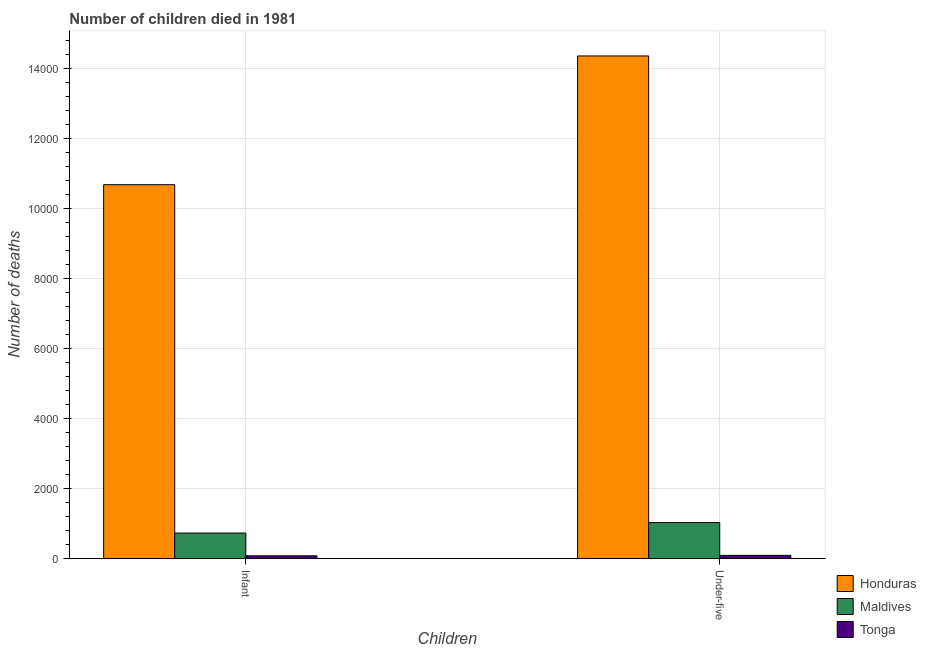How many different coloured bars are there?
Offer a terse response. 3. How many groups of bars are there?
Provide a succinct answer. 2. Are the number of bars on each tick of the X-axis equal?
Make the answer very short. Yes. How many bars are there on the 1st tick from the right?
Offer a terse response. 3. What is the label of the 1st group of bars from the left?
Your answer should be very brief. Infant. What is the number of under-five deaths in Maldives?
Your response must be concise. 1028. Across all countries, what is the maximum number of infant deaths?
Provide a short and direct response. 1.07e+04. Across all countries, what is the minimum number of under-five deaths?
Keep it short and to the point. 91. In which country was the number of under-five deaths maximum?
Make the answer very short. Honduras. In which country was the number of infant deaths minimum?
Give a very brief answer. Tonga. What is the total number of under-five deaths in the graph?
Offer a very short reply. 1.55e+04. What is the difference between the number of under-five deaths in Maldives and that in Tonga?
Your answer should be very brief. 937. What is the difference between the number of infant deaths in Maldives and the number of under-five deaths in Honduras?
Offer a very short reply. -1.36e+04. What is the average number of under-five deaths per country?
Give a very brief answer. 5157.67. What is the difference between the number of under-five deaths and number of infant deaths in Tonga?
Provide a short and direct response. 12. What is the ratio of the number of infant deaths in Honduras to that in Tonga?
Make the answer very short. 135.16. In how many countries, is the number of infant deaths greater than the average number of infant deaths taken over all countries?
Offer a terse response. 1. What does the 1st bar from the left in Under-five represents?
Make the answer very short. Honduras. What does the 1st bar from the right in Under-five represents?
Ensure brevity in your answer.  Tonga. Are all the bars in the graph horizontal?
Your response must be concise. No. Where does the legend appear in the graph?
Offer a very short reply. Bottom right. How many legend labels are there?
Provide a succinct answer. 3. How are the legend labels stacked?
Your answer should be compact. Vertical. What is the title of the graph?
Make the answer very short. Number of children died in 1981. Does "Madagascar" appear as one of the legend labels in the graph?
Ensure brevity in your answer.  No. What is the label or title of the X-axis?
Ensure brevity in your answer.  Children. What is the label or title of the Y-axis?
Make the answer very short. Number of deaths. What is the Number of deaths in Honduras in Infant?
Make the answer very short. 1.07e+04. What is the Number of deaths of Maldives in Infant?
Offer a terse response. 729. What is the Number of deaths of Tonga in Infant?
Provide a succinct answer. 79. What is the Number of deaths in Honduras in Under-five?
Keep it short and to the point. 1.44e+04. What is the Number of deaths in Maldives in Under-five?
Your response must be concise. 1028. What is the Number of deaths in Tonga in Under-five?
Your answer should be compact. 91. Across all Children, what is the maximum Number of deaths in Honduras?
Make the answer very short. 1.44e+04. Across all Children, what is the maximum Number of deaths of Maldives?
Provide a succinct answer. 1028. Across all Children, what is the maximum Number of deaths in Tonga?
Provide a short and direct response. 91. Across all Children, what is the minimum Number of deaths of Honduras?
Ensure brevity in your answer.  1.07e+04. Across all Children, what is the minimum Number of deaths in Maldives?
Make the answer very short. 729. Across all Children, what is the minimum Number of deaths in Tonga?
Give a very brief answer. 79. What is the total Number of deaths in Honduras in the graph?
Make the answer very short. 2.50e+04. What is the total Number of deaths in Maldives in the graph?
Make the answer very short. 1757. What is the total Number of deaths of Tonga in the graph?
Make the answer very short. 170. What is the difference between the Number of deaths of Honduras in Infant and that in Under-five?
Provide a succinct answer. -3676. What is the difference between the Number of deaths of Maldives in Infant and that in Under-five?
Make the answer very short. -299. What is the difference between the Number of deaths in Honduras in Infant and the Number of deaths in Maldives in Under-five?
Keep it short and to the point. 9650. What is the difference between the Number of deaths of Honduras in Infant and the Number of deaths of Tonga in Under-five?
Give a very brief answer. 1.06e+04. What is the difference between the Number of deaths of Maldives in Infant and the Number of deaths of Tonga in Under-five?
Provide a succinct answer. 638. What is the average Number of deaths in Honduras per Children?
Your answer should be compact. 1.25e+04. What is the average Number of deaths in Maldives per Children?
Your answer should be very brief. 878.5. What is the difference between the Number of deaths in Honduras and Number of deaths in Maldives in Infant?
Ensure brevity in your answer.  9949. What is the difference between the Number of deaths of Honduras and Number of deaths of Tonga in Infant?
Keep it short and to the point. 1.06e+04. What is the difference between the Number of deaths in Maldives and Number of deaths in Tonga in Infant?
Ensure brevity in your answer.  650. What is the difference between the Number of deaths in Honduras and Number of deaths in Maldives in Under-five?
Your answer should be very brief. 1.33e+04. What is the difference between the Number of deaths in Honduras and Number of deaths in Tonga in Under-five?
Ensure brevity in your answer.  1.43e+04. What is the difference between the Number of deaths of Maldives and Number of deaths of Tonga in Under-five?
Give a very brief answer. 937. What is the ratio of the Number of deaths in Honduras in Infant to that in Under-five?
Ensure brevity in your answer.  0.74. What is the ratio of the Number of deaths in Maldives in Infant to that in Under-five?
Provide a succinct answer. 0.71. What is the ratio of the Number of deaths in Tonga in Infant to that in Under-five?
Your answer should be compact. 0.87. What is the difference between the highest and the second highest Number of deaths in Honduras?
Your answer should be very brief. 3676. What is the difference between the highest and the second highest Number of deaths in Maldives?
Your response must be concise. 299. What is the difference between the highest and the second highest Number of deaths of Tonga?
Your response must be concise. 12. What is the difference between the highest and the lowest Number of deaths in Honduras?
Offer a very short reply. 3676. What is the difference between the highest and the lowest Number of deaths in Maldives?
Provide a short and direct response. 299. 